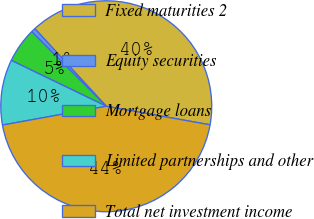Convert chart to OTSL. <chart><loc_0><loc_0><loc_500><loc_500><pie_chart><fcel>Fixed maturities 2<fcel>Equity securities<fcel>Mortgage loans<fcel>Limited partnerships and other<fcel>Total net investment income<nl><fcel>39.66%<fcel>0.66%<fcel>5.34%<fcel>10.01%<fcel>44.33%<nl></chart> 